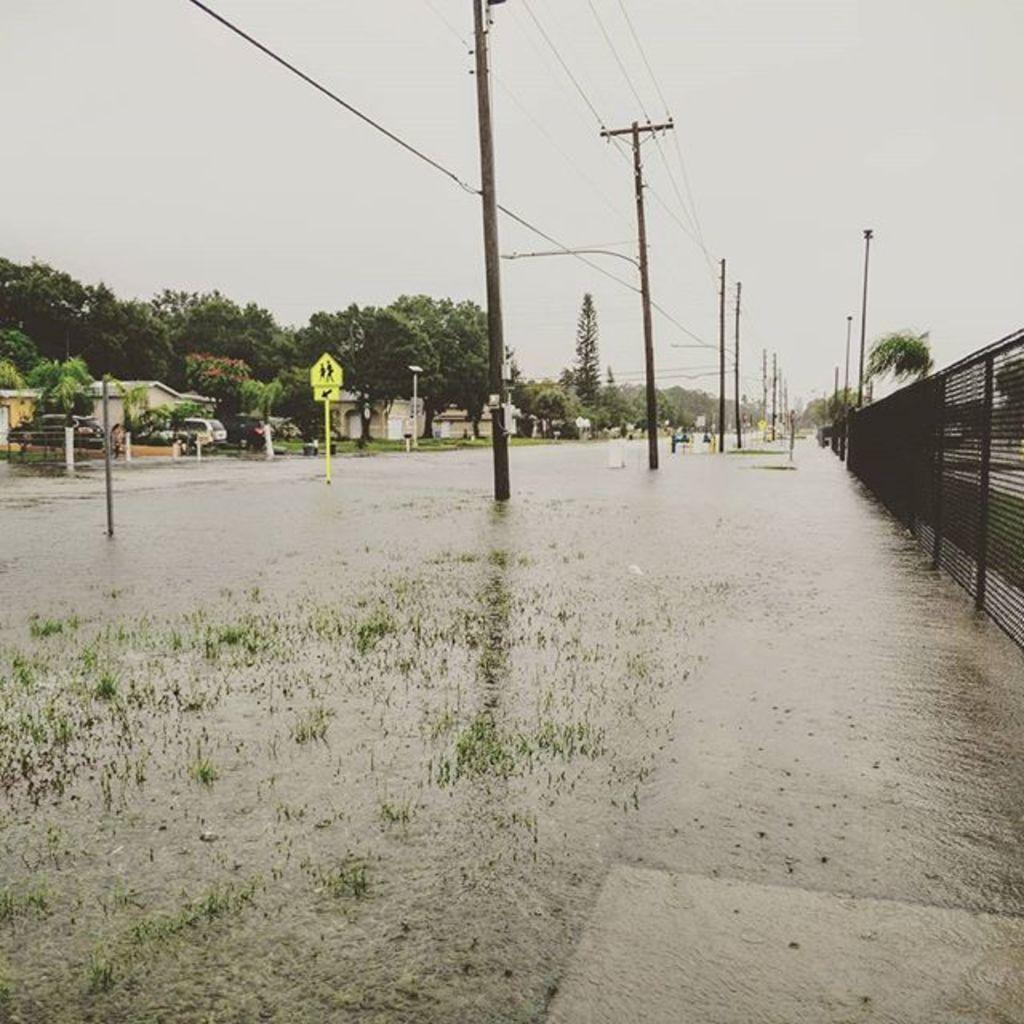What is located in the center of the image? There are poles in the center of the image. What can be seen on the right side of the image? There is a mesh on the right side of the image. What is present on the left side of the image? There is a sign board and a building on the left side of the image, as well as trees. What is visible at the top of the image? There are wires and the sky visible at the top of the image. What type of knot is being tied by the cabbage in the image? There is no cabbage or knot present in the image. Are there any police officers visible in the image? There is no mention of police officers in the provided facts, and therefore we cannot determine if any are present in the image. 